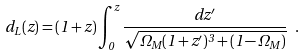<formula> <loc_0><loc_0><loc_500><loc_500>d _ { L } ( z ) = ( 1 + z ) \int _ { 0 } ^ { z } { \frac { d z ^ { \prime } } { \sqrt { \Omega _ { M } ( 1 + z ^ { \prime } ) ^ { 3 } + ( 1 - \Omega _ { M } ) } } } \ .</formula> 